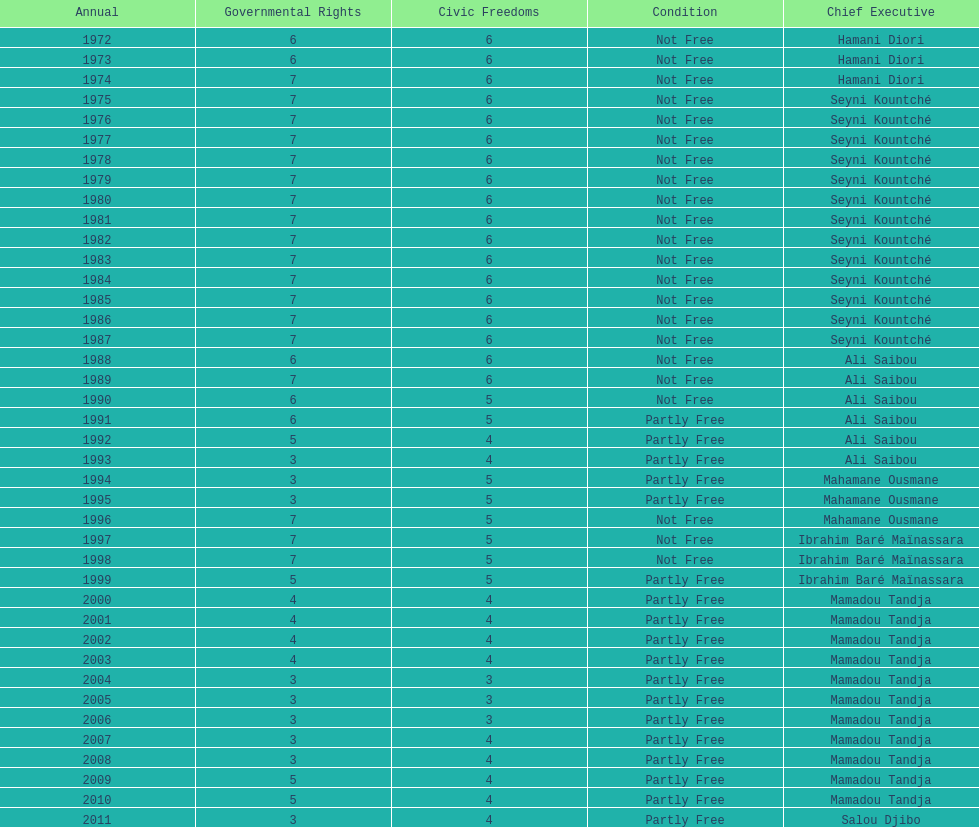What is the number of time seyni kountche has been president? 13. 